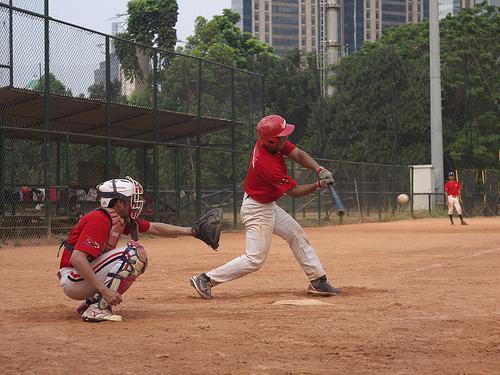How many players are in the picture?
Give a very brief answer. 3. 